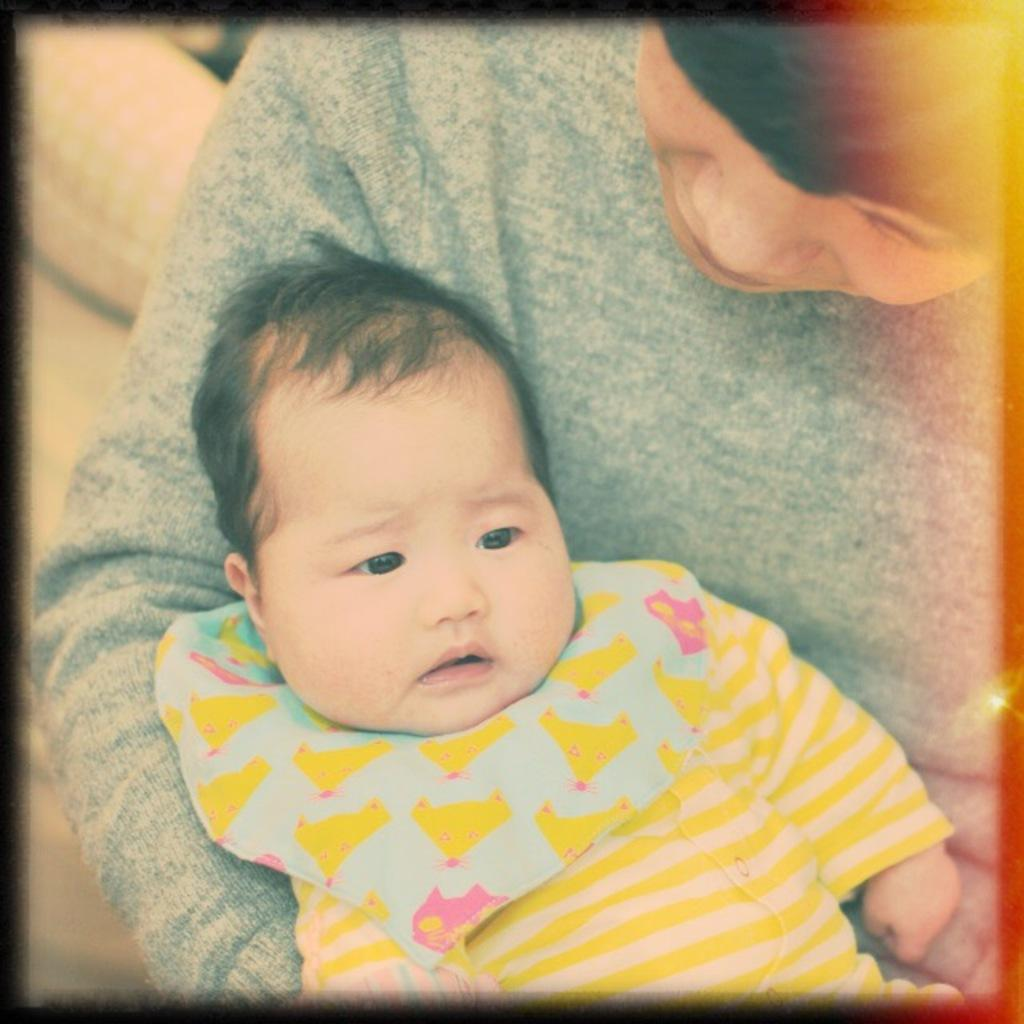Who is the main subject in the image? There is a person in the image. What is the person wearing? The person is wearing a grey T-shirt. What is the person doing in the image? The person is carrying a child. What is the child wearing? The child is wearing a yellow dress. What type of jelly is being served at the governor's event in the image? There is no governor or jelly present in the image; it features a person carrying a child. What type of cord is used to secure the child to the person in the image? There is no cord visible in the image; the person is simply carrying the child. 